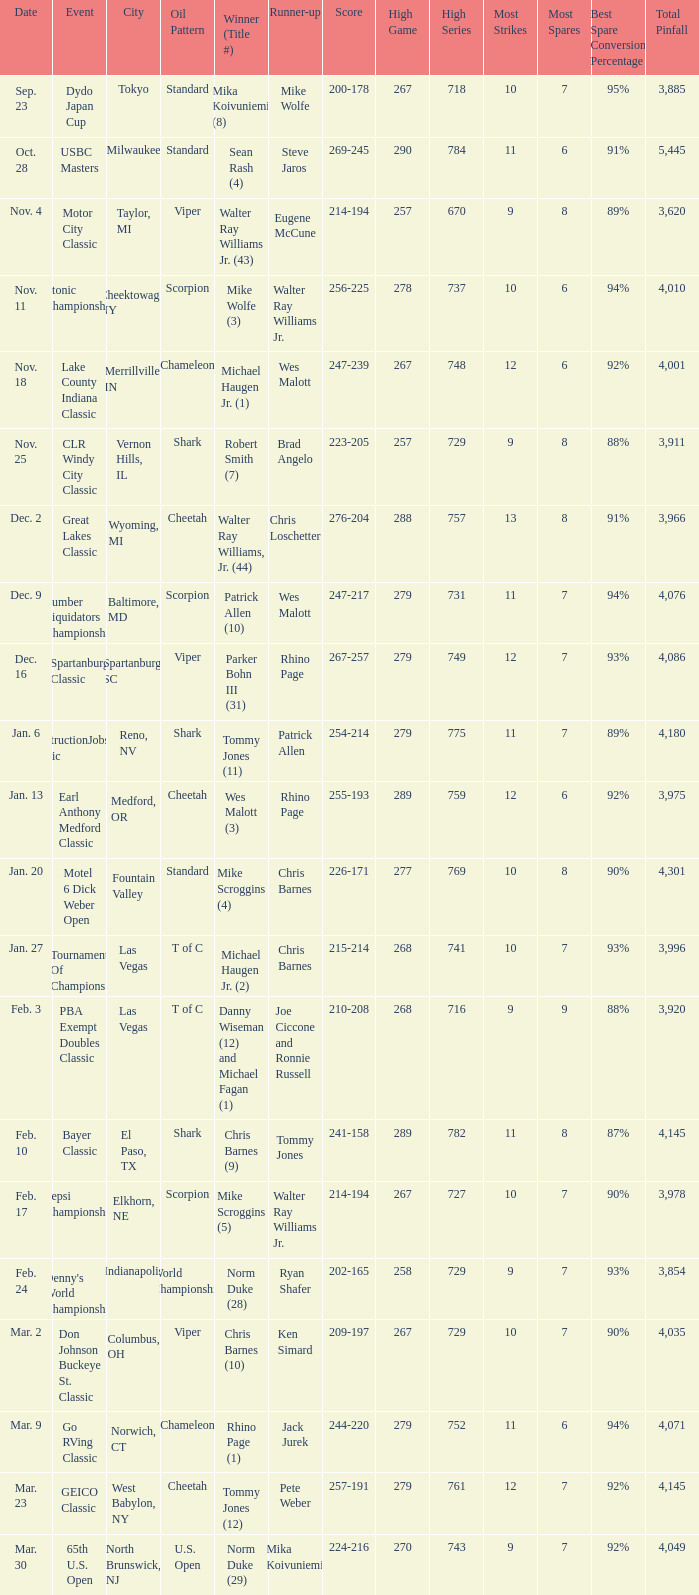Name the Event which has a Winner (Title #) of parker bohn iii (31)? Spartanburg Classic. 